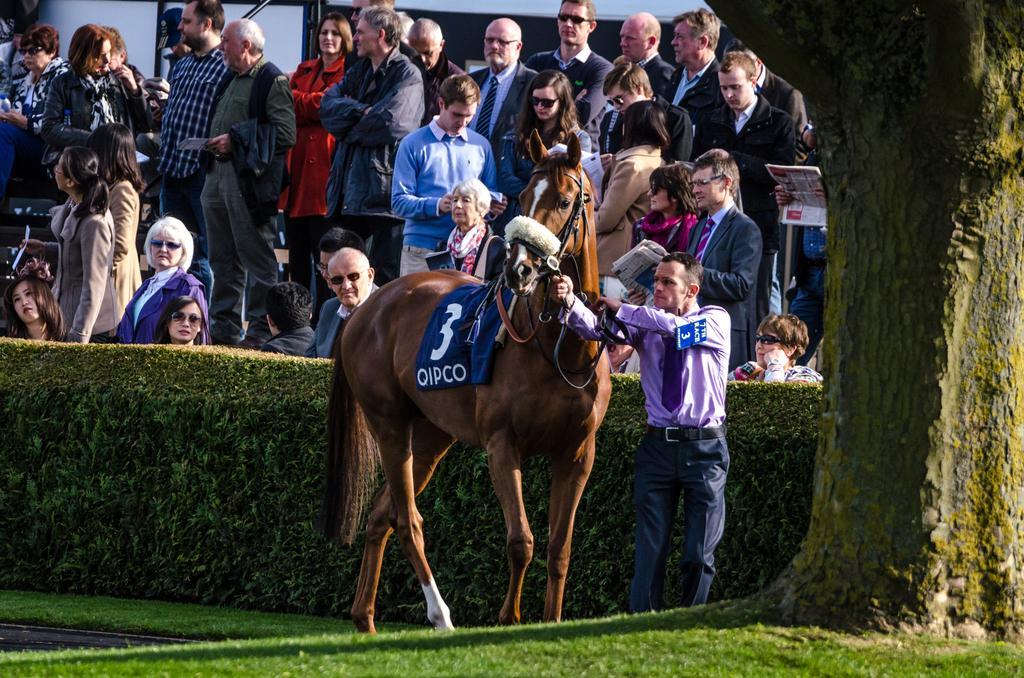Please provide a concise description of this image. In this image I can see number of people are standing where a man is standing with a horse. I can also see a plant and a tree. 